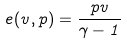<formula> <loc_0><loc_0><loc_500><loc_500>e ( v , p ) = \frac { p v } { \gamma - 1 }</formula> 